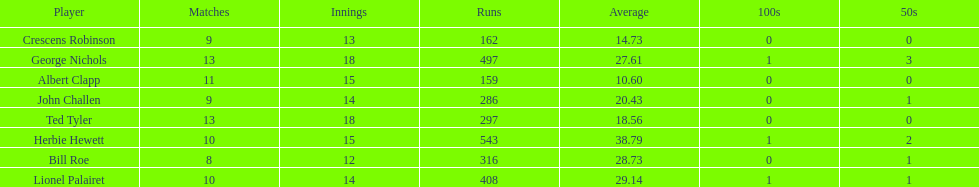Write the full table. {'header': ['Player', 'Matches', 'Innings', 'Runs', 'Average', '100s', '50s'], 'rows': [['Crescens Robinson', '9', '13', '162', '14.73', '0', '0'], ['George Nichols', '13', '18', '497', '27.61', '1', '3'], ['Albert Clapp', '11', '15', '159', '10.60', '0', '0'], ['John Challen', '9', '14', '286', '20.43', '0', '1'], ['Ted Tyler', '13', '18', '297', '18.56', '0', '0'], ['Herbie Hewett', '10', '15', '543', '38.79', '1', '2'], ['Bill Roe', '8', '12', '316', '28.73', '0', '1'], ['Lionel Palairet', '10', '14', '408', '29.14', '1', '1']]} How many more runs does john have than albert? 127. 